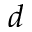<formula> <loc_0><loc_0><loc_500><loc_500>d</formula> 